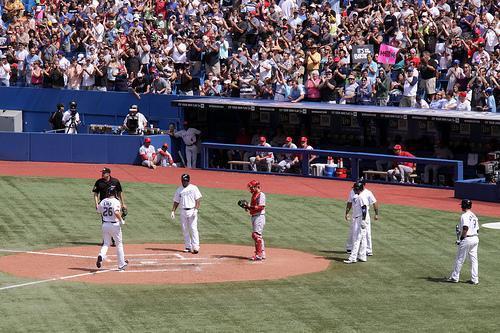How many men on field with black shirts?
Give a very brief answer. 1. 